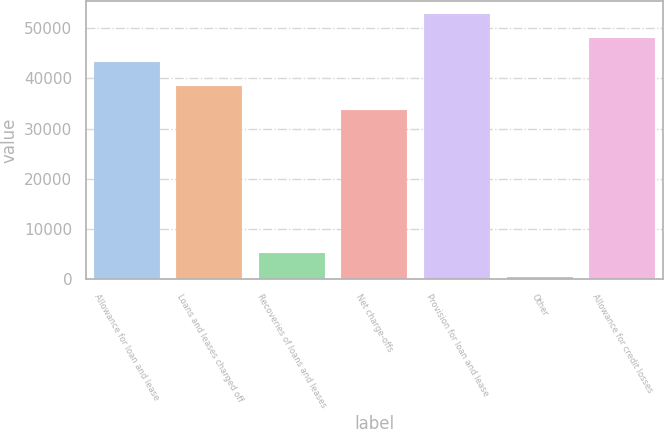Convert chart to OTSL. <chart><loc_0><loc_0><loc_500><loc_500><bar_chart><fcel>Allowance for loan and lease<fcel>Loans and leases charged off<fcel>Recoveries of loans and leases<fcel>Net charge-offs<fcel>Provision for loan and lease<fcel>Other<fcel>Allowance for credit losses<nl><fcel>43251.4<fcel>38469.7<fcel>5330.7<fcel>33688<fcel>52814.8<fcel>549<fcel>48033.1<nl></chart> 